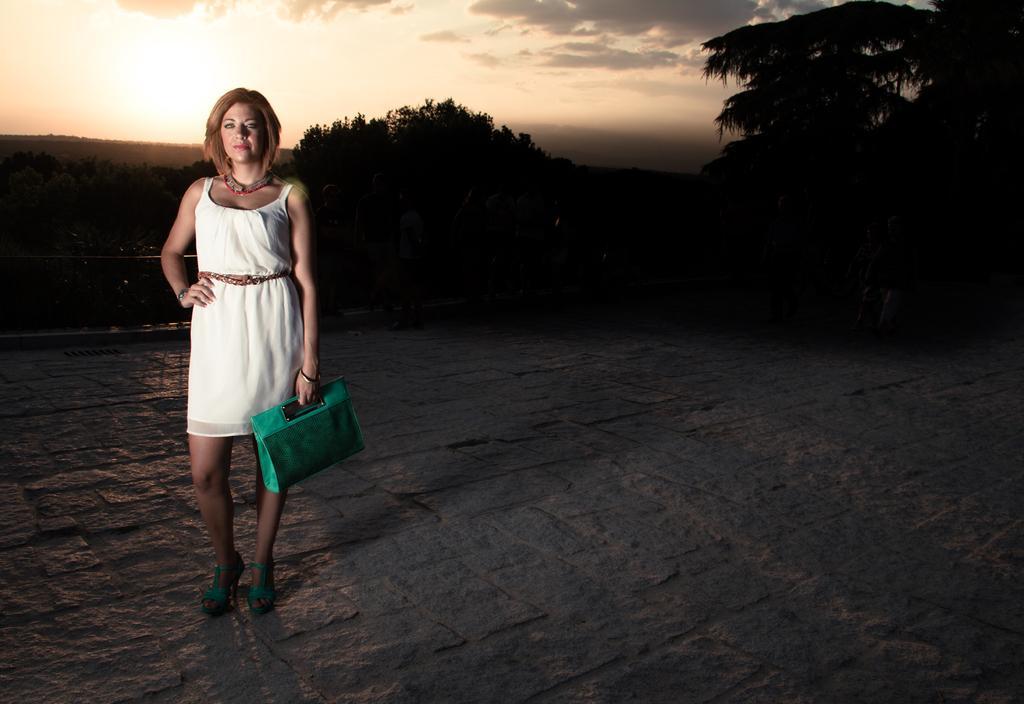Please provide a concise description of this image. It is an open area , a woman wearing white color dress and red and metal necklace is standing, she is holding a green color bag, she is wearing green color heels,in the background there is a iron rod, trees and sky that atmosphere looks like it is an evening. 